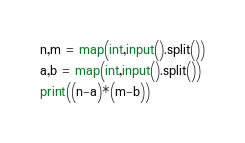<code> <loc_0><loc_0><loc_500><loc_500><_Python_>n,m = map(int,input().split())
a,b = map(int,input().split())
print((n-a)*(m-b))</code> 